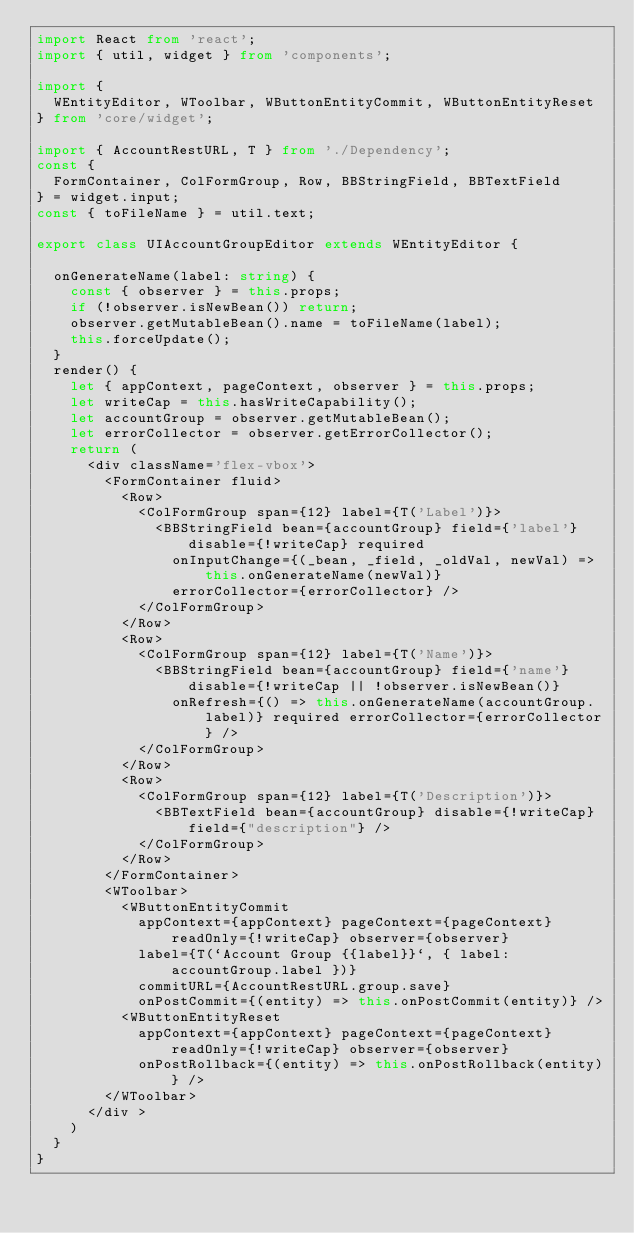Convert code to text. <code><loc_0><loc_0><loc_500><loc_500><_TypeScript_>import React from 'react';
import { util, widget } from 'components';

import {
  WEntityEditor, WToolbar, WButtonEntityCommit, WButtonEntityReset
} from 'core/widget';

import { AccountRestURL, T } from './Dependency';
const {
  FormContainer, ColFormGroup, Row, BBStringField, BBTextField
} = widget.input;
const { toFileName } = util.text;

export class UIAccountGroupEditor extends WEntityEditor {

  onGenerateName(label: string) {
    const { observer } = this.props;
    if (!observer.isNewBean()) return;
    observer.getMutableBean().name = toFileName(label);
    this.forceUpdate();
  }
  render() {
    let { appContext, pageContext, observer } = this.props;
    let writeCap = this.hasWriteCapability();
    let accountGroup = observer.getMutableBean();
    let errorCollector = observer.getErrorCollector();
    return (
      <div className='flex-vbox'>
        <FormContainer fluid>
          <Row>
            <ColFormGroup span={12} label={T('Label')}>
              <BBStringField bean={accountGroup} field={'label'} disable={!writeCap} required
                onInputChange={(_bean, _field, _oldVal, newVal) => this.onGenerateName(newVal)}
                errorCollector={errorCollector} />
            </ColFormGroup>
          </Row>
          <Row>
            <ColFormGroup span={12} label={T('Name')}>
              <BBStringField bean={accountGroup} field={'name'} disable={!writeCap || !observer.isNewBean()}
                onRefresh={() => this.onGenerateName(accountGroup.label)} required errorCollector={errorCollector} />
            </ColFormGroup>
          </Row>
          <Row>
            <ColFormGroup span={12} label={T('Description')}>
              <BBTextField bean={accountGroup} disable={!writeCap} field={"description"} />
            </ColFormGroup>
          </Row>
        </FormContainer>
        <WToolbar>
          <WButtonEntityCommit
            appContext={appContext} pageContext={pageContext} readOnly={!writeCap} observer={observer}
            label={T(`Account Group {{label}}`, { label: accountGroup.label })}
            commitURL={AccountRestURL.group.save}
            onPostCommit={(entity) => this.onPostCommit(entity)} />
          <WButtonEntityReset
            appContext={appContext} pageContext={pageContext} readOnly={!writeCap} observer={observer}
            onPostRollback={(entity) => this.onPostRollback(entity)} />
        </WToolbar>
      </div >
    )
  }
}</code> 